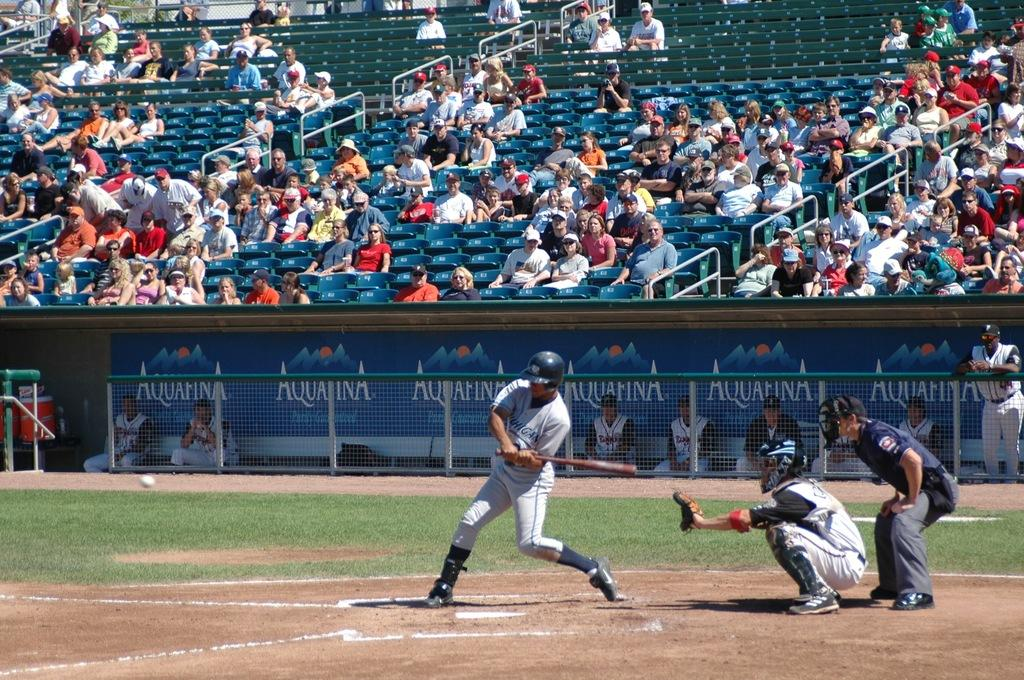<image>
Present a compact description of the photo's key features. View of a baseball ground with players and audiences sitting in the stadium that has Aquafina placards 